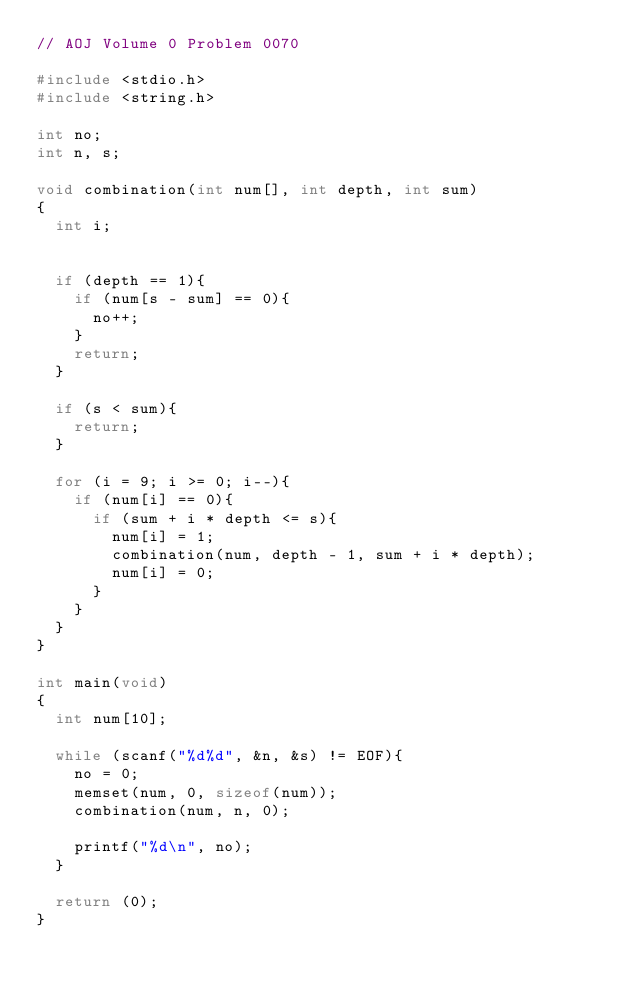<code> <loc_0><loc_0><loc_500><loc_500><_C_>// AOJ Volume 0 Problem 0070

#include <stdio.h>
#include <string.h>

int no;
int n, s;

void combination(int num[], int depth, int sum)
{
	int i;
	
	
	if (depth == 1){
		if (num[s - sum] == 0){
			no++;
		}
		return;
	}
	
	if (s < sum){
		return;
	}
	
	for (i = 9; i >= 0; i--){
		if (num[i] == 0){
			if (sum + i * depth <= s){
				num[i] = 1;
				combination(num, depth - 1, sum + i * depth);
				num[i] = 0;
			}
		}
	}
}

int main(void)
{
	int num[10];
	
	while (scanf("%d%d", &n, &s) != EOF){
		no = 0;
		memset(num, 0, sizeof(num));
		combination(num, n, 0);
		
		printf("%d\n", no);
	}
	
	return (0);
}</code> 